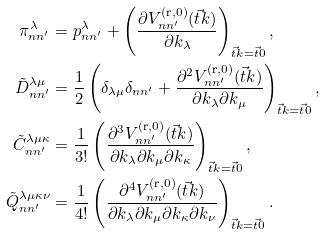<formula> <loc_0><loc_0><loc_500><loc_500>\pi _ { n n ^ { \prime } } ^ { \lambda } & = p _ { n n ^ { \prime } } ^ { \lambda } + \left ( \frac { \partial V ^ { ( \text {r} , 0 ) } _ { n n ^ { \prime } } ( \vec { t } { k } ) } { \partial k _ { \lambda } } \right ) _ { \vec { t } { k } = \vec { t } { 0 } } , \\ \tilde { D } _ { n n ^ { \prime } } ^ { \lambda \mu } & = \frac { 1 } { 2 } \left ( \delta _ { \lambda \mu } \delta _ { n n ^ { \prime } } + \frac { \partial ^ { 2 } V ^ { ( \text {r} , 0 ) } _ { n n ^ { \prime } } ( \vec { t } { k } ) } { \partial k _ { \lambda } \partial k _ { \mu } } \right ) _ { \vec { t } { k } = \vec { t } { 0 } } , \\ \tilde { C } _ { n n ^ { \prime } } ^ { \lambda \mu \kappa } & = \frac { 1 } { 3 ! } \left ( \frac { \partial ^ { 3 } V ^ { ( \text {r} , 0 ) } _ { n n ^ { \prime } } ( \vec { t } { k } ) } { \partial k _ { \lambda } \partial k _ { \mu } \partial k _ { \kappa } } \right ) _ { \vec { t } { k } = \vec { t } { 0 } } , \\ \tilde { Q } _ { n n ^ { \prime } } ^ { \lambda \mu \kappa \nu } & = \frac { 1 } { 4 ! } \left ( \frac { \partial ^ { 4 } V ^ { ( \text {r} , 0 ) } _ { n n ^ { \prime } } ( \vec { t } { k } ) } { \partial k _ { \lambda } \partial k _ { \mu } \partial k _ { \kappa } \partial k _ { \nu } } \right ) _ { \vec { t } { k } = \vec { t } { 0 } } .</formula> 